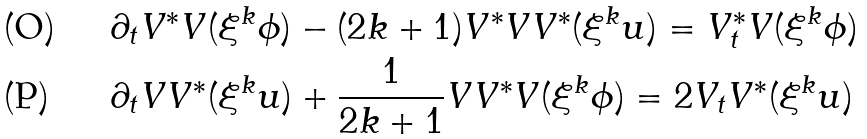<formula> <loc_0><loc_0><loc_500><loc_500>& \partial _ { t } V ^ { \ast } V ( \xi ^ { k } \phi ) - ( 2 k + 1 ) V ^ { \ast } V V ^ { \ast } ( \xi ^ { k } u ) = V _ { t } ^ { \ast } V ( \xi ^ { k } \phi ) \\ & \partial _ { t } V V ^ { \ast } ( \xi ^ { k } u ) + \frac { 1 } { 2 k + 1 } V V ^ { \ast } V ( \xi ^ { k } \phi ) = 2 V _ { t } V ^ { \ast } ( \xi ^ { k } u )</formula> 